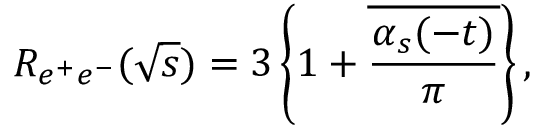<formula> <loc_0><loc_0><loc_500><loc_500>R _ { e ^ { + } e ^ { - } } ( \sqrt { s } ) = 3 \left \{ 1 + \overline { { { { \frac { \alpha _ { s } ( - t ) } { \pi } } } } } \right \} ,</formula> 